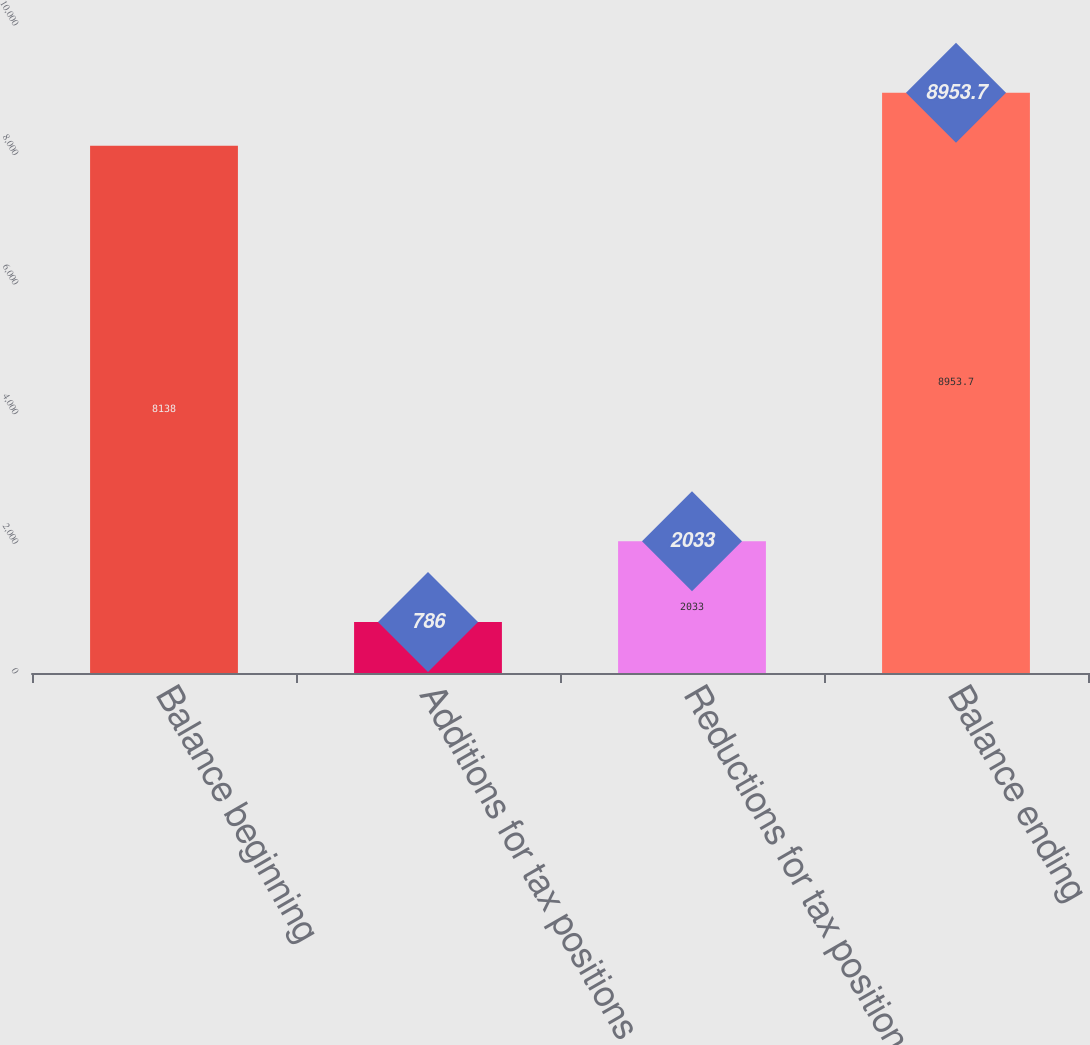Convert chart to OTSL. <chart><loc_0><loc_0><loc_500><loc_500><bar_chart><fcel>Balance beginning<fcel>Additions for tax positions<fcel>Reductions for tax positions<fcel>Balance ending<nl><fcel>8138<fcel>786<fcel>2033<fcel>8953.7<nl></chart> 